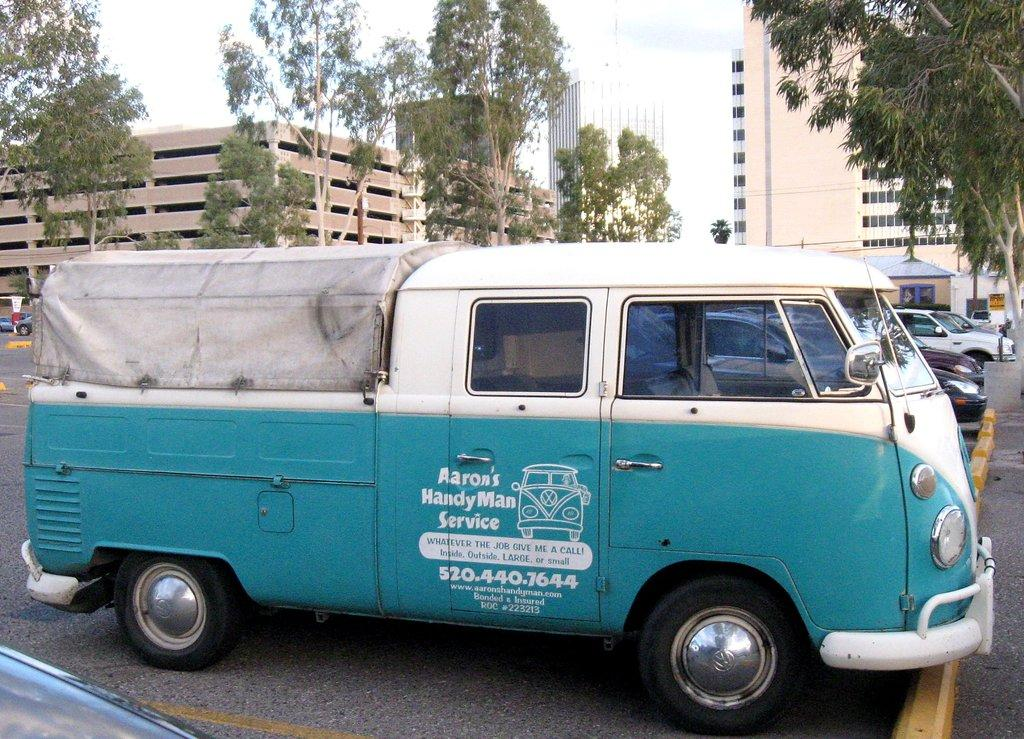What is present on the road in the image? There are vehicles on the road in the image. What can be seen in the background of the image? There are buildings and trees in the background of the image. What is visible at the top of the image? The sky is visible at the top of the image. What type of oranges are being sold in the apparel store in the image? There is no mention of oranges or an apparel store in the image; it features vehicles on the road with buildings and trees in the background. What song is playing in the background of the image? There is no information about any music or song in the image. 